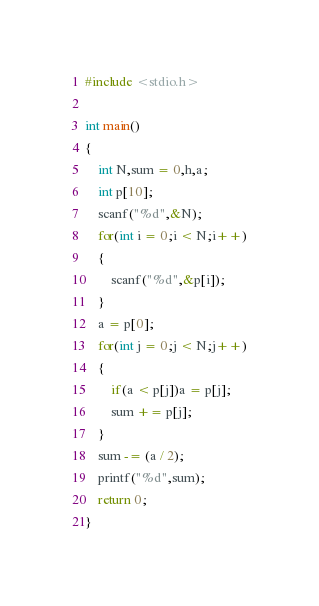Convert code to text. <code><loc_0><loc_0><loc_500><loc_500><_C_>#include <stdio.h>

int main()
{
    int N,sum = 0,h,a;
    int p[10];
    scanf("%d",&N);
    for(int i = 0;i < N;i++)
    {
        scanf("%d",&p[i]);
    }
    a = p[0];
    for(int j = 0;j < N;j++)
    {
        if(a < p[j])a = p[j];
        sum += p[j];
    }
    sum -= (a / 2);
    printf("%d",sum);
    return 0;
}</code> 